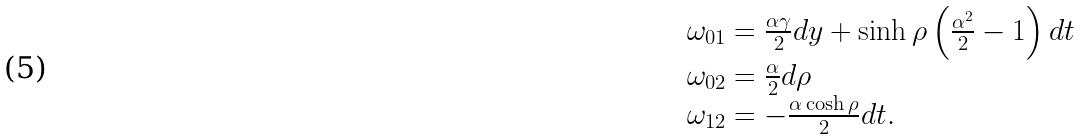Convert formula to latex. <formula><loc_0><loc_0><loc_500><loc_500>\begin{array} { l } \omega _ { 0 1 } = \frac { \alpha \gamma } { 2 } d y + \sinh \rho \left ( \frac { \alpha ^ { 2 } } { 2 } - 1 \right ) d t \\ \omega _ { 0 2 } = \frac { \alpha } { 2 } d \rho \\ \omega _ { 1 2 } = - \frac { \alpha \cosh \rho } { 2 } d t . \end{array}</formula> 